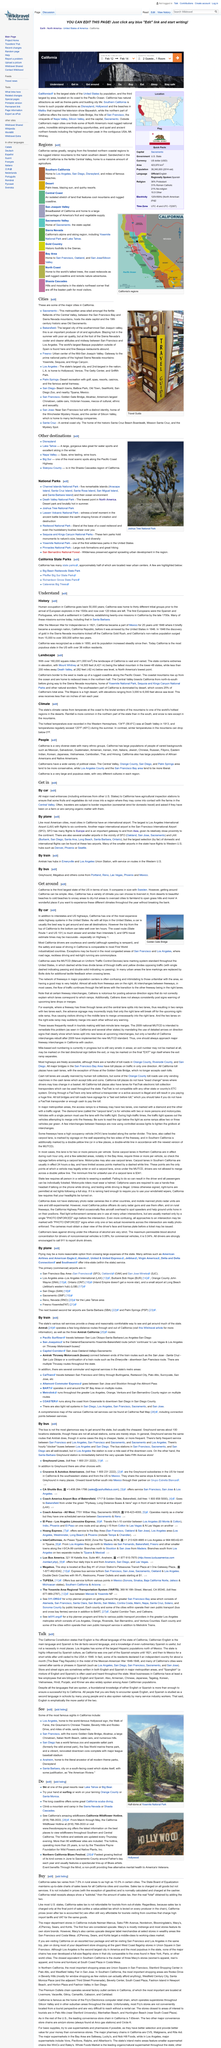Mention a couple of crucial points in this snapshot. The common places in San Francisco and Los Angeles include road rage, reckless driving, and red-light running. California was recognized as a state in the year 1850. It is best to use a car to travel to and explore different destinations as it provides the most efficient mode of transportation for covering a large area. The above picture was taken at the Golden Gate Bridge. Today, more than 38 million people live in the state of California. 